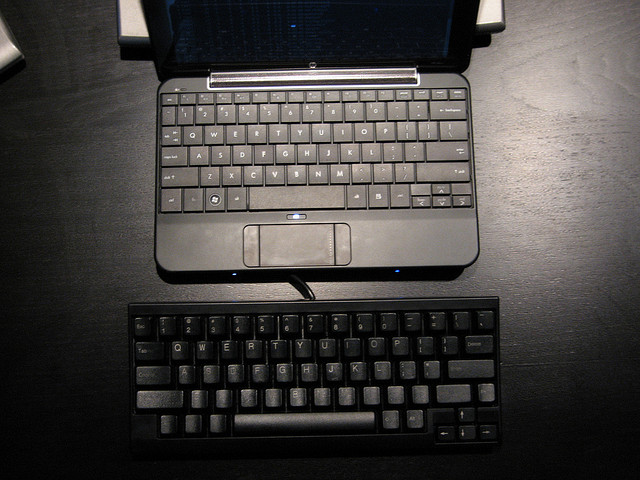Read all the text in this image. O W E T S 4 2 K J H G F O U T R E W O O O Y U J C I H O 